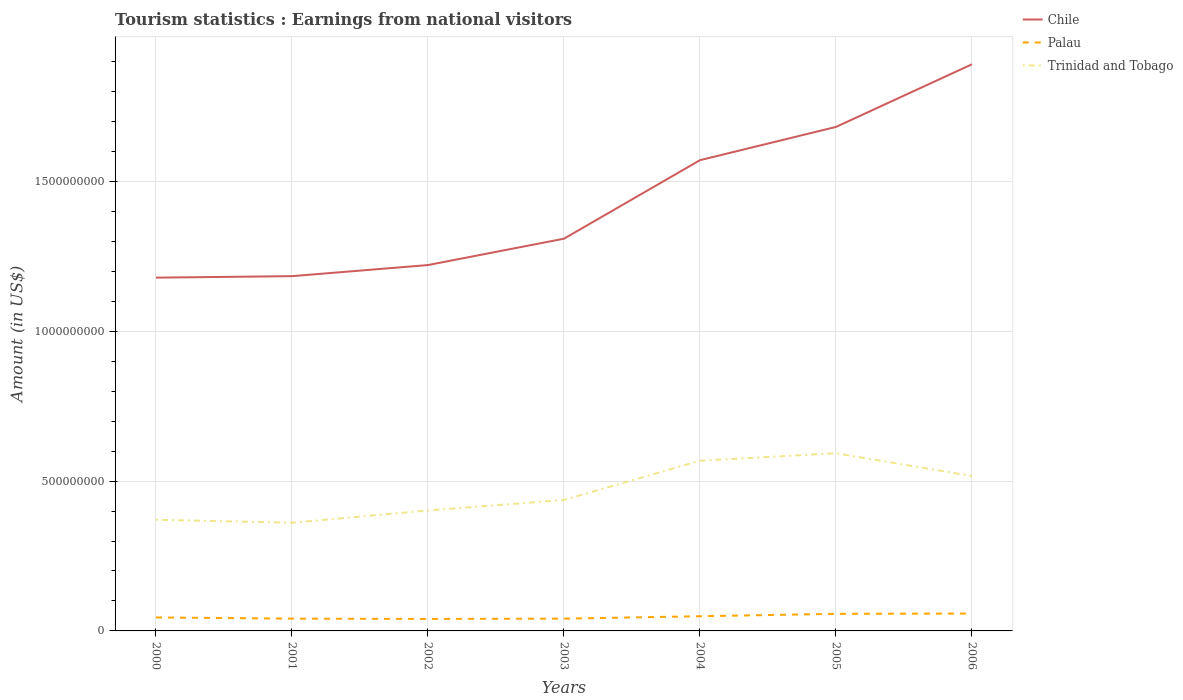Is the number of lines equal to the number of legend labels?
Keep it short and to the point. Yes. Across all years, what is the maximum earnings from national visitors in Chile?
Ensure brevity in your answer.  1.18e+09. What is the total earnings from national visitors in Trinidad and Tobago in the graph?
Provide a succinct answer. 5.10e+07. What is the difference between the highest and the second highest earnings from national visitors in Palau?
Give a very brief answer. 1.80e+07. What is the difference between the highest and the lowest earnings from national visitors in Palau?
Provide a succinct answer. 3. How many lines are there?
Make the answer very short. 3. How many years are there in the graph?
Give a very brief answer. 7. Are the values on the major ticks of Y-axis written in scientific E-notation?
Provide a short and direct response. No. Does the graph contain grids?
Make the answer very short. Yes. How are the legend labels stacked?
Your answer should be compact. Vertical. What is the title of the graph?
Your response must be concise. Tourism statistics : Earnings from national visitors. Does "Heavily indebted poor countries" appear as one of the legend labels in the graph?
Provide a succinct answer. No. What is the Amount (in US$) in Chile in 2000?
Keep it short and to the point. 1.18e+09. What is the Amount (in US$) in Palau in 2000?
Your answer should be very brief. 4.50e+07. What is the Amount (in US$) in Trinidad and Tobago in 2000?
Provide a succinct answer. 3.71e+08. What is the Amount (in US$) of Chile in 2001?
Provide a short and direct response. 1.18e+09. What is the Amount (in US$) of Palau in 2001?
Your answer should be very brief. 4.10e+07. What is the Amount (in US$) of Trinidad and Tobago in 2001?
Give a very brief answer. 3.61e+08. What is the Amount (in US$) in Chile in 2002?
Give a very brief answer. 1.22e+09. What is the Amount (in US$) of Palau in 2002?
Your answer should be very brief. 4.00e+07. What is the Amount (in US$) in Trinidad and Tobago in 2002?
Your answer should be very brief. 4.02e+08. What is the Amount (in US$) in Chile in 2003?
Ensure brevity in your answer.  1.31e+09. What is the Amount (in US$) of Palau in 2003?
Offer a terse response. 4.10e+07. What is the Amount (in US$) of Trinidad and Tobago in 2003?
Make the answer very short. 4.37e+08. What is the Amount (in US$) in Chile in 2004?
Provide a succinct answer. 1.57e+09. What is the Amount (in US$) of Palau in 2004?
Offer a very short reply. 4.90e+07. What is the Amount (in US$) of Trinidad and Tobago in 2004?
Your response must be concise. 5.68e+08. What is the Amount (in US$) in Chile in 2005?
Offer a very short reply. 1.68e+09. What is the Amount (in US$) of Palau in 2005?
Provide a succinct answer. 5.70e+07. What is the Amount (in US$) of Trinidad and Tobago in 2005?
Your answer should be compact. 5.93e+08. What is the Amount (in US$) of Chile in 2006?
Ensure brevity in your answer.  1.89e+09. What is the Amount (in US$) of Palau in 2006?
Your answer should be very brief. 5.80e+07. What is the Amount (in US$) of Trinidad and Tobago in 2006?
Your answer should be very brief. 5.17e+08. Across all years, what is the maximum Amount (in US$) of Chile?
Offer a terse response. 1.89e+09. Across all years, what is the maximum Amount (in US$) of Palau?
Provide a short and direct response. 5.80e+07. Across all years, what is the maximum Amount (in US$) of Trinidad and Tobago?
Ensure brevity in your answer.  5.93e+08. Across all years, what is the minimum Amount (in US$) in Chile?
Your answer should be very brief. 1.18e+09. Across all years, what is the minimum Amount (in US$) of Palau?
Offer a terse response. 4.00e+07. Across all years, what is the minimum Amount (in US$) of Trinidad and Tobago?
Provide a short and direct response. 3.61e+08. What is the total Amount (in US$) of Chile in the graph?
Keep it short and to the point. 1.00e+1. What is the total Amount (in US$) of Palau in the graph?
Make the answer very short. 3.31e+08. What is the total Amount (in US$) in Trinidad and Tobago in the graph?
Your answer should be compact. 3.25e+09. What is the difference between the Amount (in US$) in Chile in 2000 and that in 2001?
Offer a very short reply. -5.00e+06. What is the difference between the Amount (in US$) in Chile in 2000 and that in 2002?
Give a very brief answer. -4.20e+07. What is the difference between the Amount (in US$) of Trinidad and Tobago in 2000 and that in 2002?
Your response must be concise. -3.10e+07. What is the difference between the Amount (in US$) of Chile in 2000 and that in 2003?
Provide a succinct answer. -1.30e+08. What is the difference between the Amount (in US$) of Palau in 2000 and that in 2003?
Make the answer very short. 4.00e+06. What is the difference between the Amount (in US$) of Trinidad and Tobago in 2000 and that in 2003?
Offer a very short reply. -6.60e+07. What is the difference between the Amount (in US$) of Chile in 2000 and that in 2004?
Provide a succinct answer. -3.92e+08. What is the difference between the Amount (in US$) in Palau in 2000 and that in 2004?
Offer a terse response. -4.00e+06. What is the difference between the Amount (in US$) in Trinidad and Tobago in 2000 and that in 2004?
Provide a short and direct response. -1.97e+08. What is the difference between the Amount (in US$) of Chile in 2000 and that in 2005?
Offer a very short reply. -5.03e+08. What is the difference between the Amount (in US$) in Palau in 2000 and that in 2005?
Offer a terse response. -1.20e+07. What is the difference between the Amount (in US$) of Trinidad and Tobago in 2000 and that in 2005?
Offer a very short reply. -2.22e+08. What is the difference between the Amount (in US$) in Chile in 2000 and that in 2006?
Make the answer very short. -7.12e+08. What is the difference between the Amount (in US$) in Palau in 2000 and that in 2006?
Offer a very short reply. -1.30e+07. What is the difference between the Amount (in US$) in Trinidad and Tobago in 2000 and that in 2006?
Provide a short and direct response. -1.46e+08. What is the difference between the Amount (in US$) of Chile in 2001 and that in 2002?
Your answer should be very brief. -3.70e+07. What is the difference between the Amount (in US$) in Palau in 2001 and that in 2002?
Offer a very short reply. 1.00e+06. What is the difference between the Amount (in US$) in Trinidad and Tobago in 2001 and that in 2002?
Your answer should be compact. -4.10e+07. What is the difference between the Amount (in US$) of Chile in 2001 and that in 2003?
Your answer should be very brief. -1.25e+08. What is the difference between the Amount (in US$) in Trinidad and Tobago in 2001 and that in 2003?
Provide a succinct answer. -7.60e+07. What is the difference between the Amount (in US$) in Chile in 2001 and that in 2004?
Keep it short and to the point. -3.87e+08. What is the difference between the Amount (in US$) in Palau in 2001 and that in 2004?
Provide a succinct answer. -8.00e+06. What is the difference between the Amount (in US$) in Trinidad and Tobago in 2001 and that in 2004?
Provide a succinct answer. -2.07e+08. What is the difference between the Amount (in US$) in Chile in 2001 and that in 2005?
Provide a short and direct response. -4.98e+08. What is the difference between the Amount (in US$) in Palau in 2001 and that in 2005?
Your answer should be compact. -1.60e+07. What is the difference between the Amount (in US$) of Trinidad and Tobago in 2001 and that in 2005?
Offer a terse response. -2.32e+08. What is the difference between the Amount (in US$) of Chile in 2001 and that in 2006?
Keep it short and to the point. -7.07e+08. What is the difference between the Amount (in US$) of Palau in 2001 and that in 2006?
Your answer should be very brief. -1.70e+07. What is the difference between the Amount (in US$) in Trinidad and Tobago in 2001 and that in 2006?
Make the answer very short. -1.56e+08. What is the difference between the Amount (in US$) in Chile in 2002 and that in 2003?
Provide a succinct answer. -8.80e+07. What is the difference between the Amount (in US$) in Trinidad and Tobago in 2002 and that in 2003?
Keep it short and to the point. -3.50e+07. What is the difference between the Amount (in US$) of Chile in 2002 and that in 2004?
Offer a terse response. -3.50e+08. What is the difference between the Amount (in US$) of Palau in 2002 and that in 2004?
Provide a succinct answer. -9.00e+06. What is the difference between the Amount (in US$) in Trinidad and Tobago in 2002 and that in 2004?
Give a very brief answer. -1.66e+08. What is the difference between the Amount (in US$) in Chile in 2002 and that in 2005?
Your response must be concise. -4.61e+08. What is the difference between the Amount (in US$) of Palau in 2002 and that in 2005?
Your answer should be compact. -1.70e+07. What is the difference between the Amount (in US$) of Trinidad and Tobago in 2002 and that in 2005?
Give a very brief answer. -1.91e+08. What is the difference between the Amount (in US$) of Chile in 2002 and that in 2006?
Give a very brief answer. -6.70e+08. What is the difference between the Amount (in US$) in Palau in 2002 and that in 2006?
Ensure brevity in your answer.  -1.80e+07. What is the difference between the Amount (in US$) of Trinidad and Tobago in 2002 and that in 2006?
Your answer should be very brief. -1.15e+08. What is the difference between the Amount (in US$) in Chile in 2003 and that in 2004?
Provide a short and direct response. -2.62e+08. What is the difference between the Amount (in US$) in Palau in 2003 and that in 2004?
Offer a very short reply. -8.00e+06. What is the difference between the Amount (in US$) of Trinidad and Tobago in 2003 and that in 2004?
Keep it short and to the point. -1.31e+08. What is the difference between the Amount (in US$) of Chile in 2003 and that in 2005?
Give a very brief answer. -3.73e+08. What is the difference between the Amount (in US$) of Palau in 2003 and that in 2005?
Provide a succinct answer. -1.60e+07. What is the difference between the Amount (in US$) in Trinidad and Tobago in 2003 and that in 2005?
Provide a succinct answer. -1.56e+08. What is the difference between the Amount (in US$) of Chile in 2003 and that in 2006?
Your response must be concise. -5.82e+08. What is the difference between the Amount (in US$) of Palau in 2003 and that in 2006?
Give a very brief answer. -1.70e+07. What is the difference between the Amount (in US$) in Trinidad and Tobago in 2003 and that in 2006?
Your answer should be compact. -8.00e+07. What is the difference between the Amount (in US$) of Chile in 2004 and that in 2005?
Your response must be concise. -1.11e+08. What is the difference between the Amount (in US$) in Palau in 2004 and that in 2005?
Make the answer very short. -8.00e+06. What is the difference between the Amount (in US$) of Trinidad and Tobago in 2004 and that in 2005?
Give a very brief answer. -2.50e+07. What is the difference between the Amount (in US$) in Chile in 2004 and that in 2006?
Provide a short and direct response. -3.20e+08. What is the difference between the Amount (in US$) of Palau in 2004 and that in 2006?
Provide a succinct answer. -9.00e+06. What is the difference between the Amount (in US$) in Trinidad and Tobago in 2004 and that in 2006?
Make the answer very short. 5.10e+07. What is the difference between the Amount (in US$) in Chile in 2005 and that in 2006?
Your answer should be very brief. -2.09e+08. What is the difference between the Amount (in US$) in Trinidad and Tobago in 2005 and that in 2006?
Your answer should be compact. 7.60e+07. What is the difference between the Amount (in US$) in Chile in 2000 and the Amount (in US$) in Palau in 2001?
Offer a very short reply. 1.14e+09. What is the difference between the Amount (in US$) of Chile in 2000 and the Amount (in US$) of Trinidad and Tobago in 2001?
Your response must be concise. 8.18e+08. What is the difference between the Amount (in US$) in Palau in 2000 and the Amount (in US$) in Trinidad and Tobago in 2001?
Your answer should be very brief. -3.16e+08. What is the difference between the Amount (in US$) in Chile in 2000 and the Amount (in US$) in Palau in 2002?
Offer a very short reply. 1.14e+09. What is the difference between the Amount (in US$) of Chile in 2000 and the Amount (in US$) of Trinidad and Tobago in 2002?
Your response must be concise. 7.77e+08. What is the difference between the Amount (in US$) in Palau in 2000 and the Amount (in US$) in Trinidad and Tobago in 2002?
Your answer should be compact. -3.57e+08. What is the difference between the Amount (in US$) of Chile in 2000 and the Amount (in US$) of Palau in 2003?
Provide a short and direct response. 1.14e+09. What is the difference between the Amount (in US$) in Chile in 2000 and the Amount (in US$) in Trinidad and Tobago in 2003?
Your answer should be very brief. 7.42e+08. What is the difference between the Amount (in US$) of Palau in 2000 and the Amount (in US$) of Trinidad and Tobago in 2003?
Make the answer very short. -3.92e+08. What is the difference between the Amount (in US$) of Chile in 2000 and the Amount (in US$) of Palau in 2004?
Your answer should be very brief. 1.13e+09. What is the difference between the Amount (in US$) in Chile in 2000 and the Amount (in US$) in Trinidad and Tobago in 2004?
Your response must be concise. 6.11e+08. What is the difference between the Amount (in US$) of Palau in 2000 and the Amount (in US$) of Trinidad and Tobago in 2004?
Provide a short and direct response. -5.23e+08. What is the difference between the Amount (in US$) in Chile in 2000 and the Amount (in US$) in Palau in 2005?
Your answer should be compact. 1.12e+09. What is the difference between the Amount (in US$) in Chile in 2000 and the Amount (in US$) in Trinidad and Tobago in 2005?
Provide a short and direct response. 5.86e+08. What is the difference between the Amount (in US$) in Palau in 2000 and the Amount (in US$) in Trinidad and Tobago in 2005?
Make the answer very short. -5.48e+08. What is the difference between the Amount (in US$) of Chile in 2000 and the Amount (in US$) of Palau in 2006?
Ensure brevity in your answer.  1.12e+09. What is the difference between the Amount (in US$) of Chile in 2000 and the Amount (in US$) of Trinidad and Tobago in 2006?
Your answer should be compact. 6.62e+08. What is the difference between the Amount (in US$) of Palau in 2000 and the Amount (in US$) of Trinidad and Tobago in 2006?
Offer a terse response. -4.72e+08. What is the difference between the Amount (in US$) of Chile in 2001 and the Amount (in US$) of Palau in 2002?
Make the answer very short. 1.14e+09. What is the difference between the Amount (in US$) in Chile in 2001 and the Amount (in US$) in Trinidad and Tobago in 2002?
Make the answer very short. 7.82e+08. What is the difference between the Amount (in US$) in Palau in 2001 and the Amount (in US$) in Trinidad and Tobago in 2002?
Your answer should be compact. -3.61e+08. What is the difference between the Amount (in US$) of Chile in 2001 and the Amount (in US$) of Palau in 2003?
Your response must be concise. 1.14e+09. What is the difference between the Amount (in US$) in Chile in 2001 and the Amount (in US$) in Trinidad and Tobago in 2003?
Provide a succinct answer. 7.47e+08. What is the difference between the Amount (in US$) of Palau in 2001 and the Amount (in US$) of Trinidad and Tobago in 2003?
Your response must be concise. -3.96e+08. What is the difference between the Amount (in US$) of Chile in 2001 and the Amount (in US$) of Palau in 2004?
Keep it short and to the point. 1.14e+09. What is the difference between the Amount (in US$) in Chile in 2001 and the Amount (in US$) in Trinidad and Tobago in 2004?
Ensure brevity in your answer.  6.16e+08. What is the difference between the Amount (in US$) in Palau in 2001 and the Amount (in US$) in Trinidad and Tobago in 2004?
Make the answer very short. -5.27e+08. What is the difference between the Amount (in US$) in Chile in 2001 and the Amount (in US$) in Palau in 2005?
Your answer should be very brief. 1.13e+09. What is the difference between the Amount (in US$) of Chile in 2001 and the Amount (in US$) of Trinidad and Tobago in 2005?
Your response must be concise. 5.91e+08. What is the difference between the Amount (in US$) in Palau in 2001 and the Amount (in US$) in Trinidad and Tobago in 2005?
Ensure brevity in your answer.  -5.52e+08. What is the difference between the Amount (in US$) of Chile in 2001 and the Amount (in US$) of Palau in 2006?
Keep it short and to the point. 1.13e+09. What is the difference between the Amount (in US$) in Chile in 2001 and the Amount (in US$) in Trinidad and Tobago in 2006?
Offer a very short reply. 6.67e+08. What is the difference between the Amount (in US$) of Palau in 2001 and the Amount (in US$) of Trinidad and Tobago in 2006?
Offer a very short reply. -4.76e+08. What is the difference between the Amount (in US$) in Chile in 2002 and the Amount (in US$) in Palau in 2003?
Provide a succinct answer. 1.18e+09. What is the difference between the Amount (in US$) in Chile in 2002 and the Amount (in US$) in Trinidad and Tobago in 2003?
Give a very brief answer. 7.84e+08. What is the difference between the Amount (in US$) in Palau in 2002 and the Amount (in US$) in Trinidad and Tobago in 2003?
Your answer should be compact. -3.97e+08. What is the difference between the Amount (in US$) in Chile in 2002 and the Amount (in US$) in Palau in 2004?
Offer a terse response. 1.17e+09. What is the difference between the Amount (in US$) in Chile in 2002 and the Amount (in US$) in Trinidad and Tobago in 2004?
Ensure brevity in your answer.  6.53e+08. What is the difference between the Amount (in US$) of Palau in 2002 and the Amount (in US$) of Trinidad and Tobago in 2004?
Provide a succinct answer. -5.28e+08. What is the difference between the Amount (in US$) of Chile in 2002 and the Amount (in US$) of Palau in 2005?
Give a very brief answer. 1.16e+09. What is the difference between the Amount (in US$) of Chile in 2002 and the Amount (in US$) of Trinidad and Tobago in 2005?
Keep it short and to the point. 6.28e+08. What is the difference between the Amount (in US$) of Palau in 2002 and the Amount (in US$) of Trinidad and Tobago in 2005?
Your answer should be compact. -5.53e+08. What is the difference between the Amount (in US$) of Chile in 2002 and the Amount (in US$) of Palau in 2006?
Your answer should be compact. 1.16e+09. What is the difference between the Amount (in US$) in Chile in 2002 and the Amount (in US$) in Trinidad and Tobago in 2006?
Offer a very short reply. 7.04e+08. What is the difference between the Amount (in US$) in Palau in 2002 and the Amount (in US$) in Trinidad and Tobago in 2006?
Keep it short and to the point. -4.77e+08. What is the difference between the Amount (in US$) of Chile in 2003 and the Amount (in US$) of Palau in 2004?
Provide a succinct answer. 1.26e+09. What is the difference between the Amount (in US$) in Chile in 2003 and the Amount (in US$) in Trinidad and Tobago in 2004?
Keep it short and to the point. 7.41e+08. What is the difference between the Amount (in US$) of Palau in 2003 and the Amount (in US$) of Trinidad and Tobago in 2004?
Offer a terse response. -5.27e+08. What is the difference between the Amount (in US$) of Chile in 2003 and the Amount (in US$) of Palau in 2005?
Provide a succinct answer. 1.25e+09. What is the difference between the Amount (in US$) of Chile in 2003 and the Amount (in US$) of Trinidad and Tobago in 2005?
Provide a succinct answer. 7.16e+08. What is the difference between the Amount (in US$) in Palau in 2003 and the Amount (in US$) in Trinidad and Tobago in 2005?
Your answer should be compact. -5.52e+08. What is the difference between the Amount (in US$) of Chile in 2003 and the Amount (in US$) of Palau in 2006?
Your answer should be very brief. 1.25e+09. What is the difference between the Amount (in US$) in Chile in 2003 and the Amount (in US$) in Trinidad and Tobago in 2006?
Keep it short and to the point. 7.92e+08. What is the difference between the Amount (in US$) of Palau in 2003 and the Amount (in US$) of Trinidad and Tobago in 2006?
Provide a short and direct response. -4.76e+08. What is the difference between the Amount (in US$) of Chile in 2004 and the Amount (in US$) of Palau in 2005?
Your response must be concise. 1.51e+09. What is the difference between the Amount (in US$) in Chile in 2004 and the Amount (in US$) in Trinidad and Tobago in 2005?
Make the answer very short. 9.78e+08. What is the difference between the Amount (in US$) of Palau in 2004 and the Amount (in US$) of Trinidad and Tobago in 2005?
Make the answer very short. -5.44e+08. What is the difference between the Amount (in US$) of Chile in 2004 and the Amount (in US$) of Palau in 2006?
Give a very brief answer. 1.51e+09. What is the difference between the Amount (in US$) in Chile in 2004 and the Amount (in US$) in Trinidad and Tobago in 2006?
Make the answer very short. 1.05e+09. What is the difference between the Amount (in US$) in Palau in 2004 and the Amount (in US$) in Trinidad and Tobago in 2006?
Provide a short and direct response. -4.68e+08. What is the difference between the Amount (in US$) in Chile in 2005 and the Amount (in US$) in Palau in 2006?
Your answer should be compact. 1.62e+09. What is the difference between the Amount (in US$) in Chile in 2005 and the Amount (in US$) in Trinidad and Tobago in 2006?
Give a very brief answer. 1.16e+09. What is the difference between the Amount (in US$) in Palau in 2005 and the Amount (in US$) in Trinidad and Tobago in 2006?
Give a very brief answer. -4.60e+08. What is the average Amount (in US$) of Chile per year?
Provide a short and direct response. 1.43e+09. What is the average Amount (in US$) in Palau per year?
Make the answer very short. 4.73e+07. What is the average Amount (in US$) of Trinidad and Tobago per year?
Offer a terse response. 4.64e+08. In the year 2000, what is the difference between the Amount (in US$) of Chile and Amount (in US$) of Palau?
Your answer should be very brief. 1.13e+09. In the year 2000, what is the difference between the Amount (in US$) of Chile and Amount (in US$) of Trinidad and Tobago?
Give a very brief answer. 8.08e+08. In the year 2000, what is the difference between the Amount (in US$) of Palau and Amount (in US$) of Trinidad and Tobago?
Give a very brief answer. -3.26e+08. In the year 2001, what is the difference between the Amount (in US$) in Chile and Amount (in US$) in Palau?
Your answer should be very brief. 1.14e+09. In the year 2001, what is the difference between the Amount (in US$) in Chile and Amount (in US$) in Trinidad and Tobago?
Offer a very short reply. 8.23e+08. In the year 2001, what is the difference between the Amount (in US$) of Palau and Amount (in US$) of Trinidad and Tobago?
Give a very brief answer. -3.20e+08. In the year 2002, what is the difference between the Amount (in US$) of Chile and Amount (in US$) of Palau?
Your answer should be very brief. 1.18e+09. In the year 2002, what is the difference between the Amount (in US$) of Chile and Amount (in US$) of Trinidad and Tobago?
Your answer should be compact. 8.19e+08. In the year 2002, what is the difference between the Amount (in US$) in Palau and Amount (in US$) in Trinidad and Tobago?
Make the answer very short. -3.62e+08. In the year 2003, what is the difference between the Amount (in US$) of Chile and Amount (in US$) of Palau?
Your answer should be very brief. 1.27e+09. In the year 2003, what is the difference between the Amount (in US$) in Chile and Amount (in US$) in Trinidad and Tobago?
Your answer should be very brief. 8.72e+08. In the year 2003, what is the difference between the Amount (in US$) in Palau and Amount (in US$) in Trinidad and Tobago?
Your answer should be compact. -3.96e+08. In the year 2004, what is the difference between the Amount (in US$) of Chile and Amount (in US$) of Palau?
Your answer should be very brief. 1.52e+09. In the year 2004, what is the difference between the Amount (in US$) of Chile and Amount (in US$) of Trinidad and Tobago?
Ensure brevity in your answer.  1.00e+09. In the year 2004, what is the difference between the Amount (in US$) of Palau and Amount (in US$) of Trinidad and Tobago?
Provide a short and direct response. -5.19e+08. In the year 2005, what is the difference between the Amount (in US$) of Chile and Amount (in US$) of Palau?
Provide a short and direct response. 1.62e+09. In the year 2005, what is the difference between the Amount (in US$) of Chile and Amount (in US$) of Trinidad and Tobago?
Your answer should be very brief. 1.09e+09. In the year 2005, what is the difference between the Amount (in US$) of Palau and Amount (in US$) of Trinidad and Tobago?
Keep it short and to the point. -5.36e+08. In the year 2006, what is the difference between the Amount (in US$) of Chile and Amount (in US$) of Palau?
Keep it short and to the point. 1.83e+09. In the year 2006, what is the difference between the Amount (in US$) of Chile and Amount (in US$) of Trinidad and Tobago?
Provide a short and direct response. 1.37e+09. In the year 2006, what is the difference between the Amount (in US$) of Palau and Amount (in US$) of Trinidad and Tobago?
Provide a succinct answer. -4.59e+08. What is the ratio of the Amount (in US$) in Palau in 2000 to that in 2001?
Give a very brief answer. 1.1. What is the ratio of the Amount (in US$) in Trinidad and Tobago in 2000 to that in 2001?
Offer a very short reply. 1.03. What is the ratio of the Amount (in US$) of Chile in 2000 to that in 2002?
Your answer should be very brief. 0.97. What is the ratio of the Amount (in US$) of Trinidad and Tobago in 2000 to that in 2002?
Provide a succinct answer. 0.92. What is the ratio of the Amount (in US$) in Chile in 2000 to that in 2003?
Your answer should be very brief. 0.9. What is the ratio of the Amount (in US$) of Palau in 2000 to that in 2003?
Your answer should be very brief. 1.1. What is the ratio of the Amount (in US$) in Trinidad and Tobago in 2000 to that in 2003?
Provide a short and direct response. 0.85. What is the ratio of the Amount (in US$) of Chile in 2000 to that in 2004?
Offer a very short reply. 0.75. What is the ratio of the Amount (in US$) of Palau in 2000 to that in 2004?
Ensure brevity in your answer.  0.92. What is the ratio of the Amount (in US$) of Trinidad and Tobago in 2000 to that in 2004?
Provide a short and direct response. 0.65. What is the ratio of the Amount (in US$) in Chile in 2000 to that in 2005?
Provide a succinct answer. 0.7. What is the ratio of the Amount (in US$) in Palau in 2000 to that in 2005?
Give a very brief answer. 0.79. What is the ratio of the Amount (in US$) in Trinidad and Tobago in 2000 to that in 2005?
Offer a very short reply. 0.63. What is the ratio of the Amount (in US$) in Chile in 2000 to that in 2006?
Ensure brevity in your answer.  0.62. What is the ratio of the Amount (in US$) in Palau in 2000 to that in 2006?
Keep it short and to the point. 0.78. What is the ratio of the Amount (in US$) of Trinidad and Tobago in 2000 to that in 2006?
Give a very brief answer. 0.72. What is the ratio of the Amount (in US$) of Chile in 2001 to that in 2002?
Provide a short and direct response. 0.97. What is the ratio of the Amount (in US$) in Palau in 2001 to that in 2002?
Offer a very short reply. 1.02. What is the ratio of the Amount (in US$) in Trinidad and Tobago in 2001 to that in 2002?
Your answer should be compact. 0.9. What is the ratio of the Amount (in US$) in Chile in 2001 to that in 2003?
Offer a very short reply. 0.9. What is the ratio of the Amount (in US$) in Trinidad and Tobago in 2001 to that in 2003?
Offer a terse response. 0.83. What is the ratio of the Amount (in US$) in Chile in 2001 to that in 2004?
Keep it short and to the point. 0.75. What is the ratio of the Amount (in US$) of Palau in 2001 to that in 2004?
Offer a very short reply. 0.84. What is the ratio of the Amount (in US$) in Trinidad and Tobago in 2001 to that in 2004?
Ensure brevity in your answer.  0.64. What is the ratio of the Amount (in US$) of Chile in 2001 to that in 2005?
Your answer should be compact. 0.7. What is the ratio of the Amount (in US$) of Palau in 2001 to that in 2005?
Offer a terse response. 0.72. What is the ratio of the Amount (in US$) of Trinidad and Tobago in 2001 to that in 2005?
Make the answer very short. 0.61. What is the ratio of the Amount (in US$) of Chile in 2001 to that in 2006?
Offer a very short reply. 0.63. What is the ratio of the Amount (in US$) in Palau in 2001 to that in 2006?
Offer a terse response. 0.71. What is the ratio of the Amount (in US$) of Trinidad and Tobago in 2001 to that in 2006?
Provide a succinct answer. 0.7. What is the ratio of the Amount (in US$) of Chile in 2002 to that in 2003?
Provide a short and direct response. 0.93. What is the ratio of the Amount (in US$) in Palau in 2002 to that in 2003?
Provide a succinct answer. 0.98. What is the ratio of the Amount (in US$) of Trinidad and Tobago in 2002 to that in 2003?
Offer a very short reply. 0.92. What is the ratio of the Amount (in US$) of Chile in 2002 to that in 2004?
Make the answer very short. 0.78. What is the ratio of the Amount (in US$) in Palau in 2002 to that in 2004?
Provide a short and direct response. 0.82. What is the ratio of the Amount (in US$) in Trinidad and Tobago in 2002 to that in 2004?
Keep it short and to the point. 0.71. What is the ratio of the Amount (in US$) of Chile in 2002 to that in 2005?
Give a very brief answer. 0.73. What is the ratio of the Amount (in US$) in Palau in 2002 to that in 2005?
Your answer should be compact. 0.7. What is the ratio of the Amount (in US$) in Trinidad and Tobago in 2002 to that in 2005?
Provide a short and direct response. 0.68. What is the ratio of the Amount (in US$) of Chile in 2002 to that in 2006?
Your answer should be very brief. 0.65. What is the ratio of the Amount (in US$) of Palau in 2002 to that in 2006?
Keep it short and to the point. 0.69. What is the ratio of the Amount (in US$) in Trinidad and Tobago in 2002 to that in 2006?
Ensure brevity in your answer.  0.78. What is the ratio of the Amount (in US$) of Chile in 2003 to that in 2004?
Keep it short and to the point. 0.83. What is the ratio of the Amount (in US$) in Palau in 2003 to that in 2004?
Give a very brief answer. 0.84. What is the ratio of the Amount (in US$) of Trinidad and Tobago in 2003 to that in 2004?
Your answer should be compact. 0.77. What is the ratio of the Amount (in US$) of Chile in 2003 to that in 2005?
Your answer should be compact. 0.78. What is the ratio of the Amount (in US$) in Palau in 2003 to that in 2005?
Give a very brief answer. 0.72. What is the ratio of the Amount (in US$) of Trinidad and Tobago in 2003 to that in 2005?
Provide a succinct answer. 0.74. What is the ratio of the Amount (in US$) in Chile in 2003 to that in 2006?
Offer a terse response. 0.69. What is the ratio of the Amount (in US$) in Palau in 2003 to that in 2006?
Provide a short and direct response. 0.71. What is the ratio of the Amount (in US$) of Trinidad and Tobago in 2003 to that in 2006?
Provide a succinct answer. 0.85. What is the ratio of the Amount (in US$) of Chile in 2004 to that in 2005?
Keep it short and to the point. 0.93. What is the ratio of the Amount (in US$) in Palau in 2004 to that in 2005?
Offer a very short reply. 0.86. What is the ratio of the Amount (in US$) in Trinidad and Tobago in 2004 to that in 2005?
Make the answer very short. 0.96. What is the ratio of the Amount (in US$) in Chile in 2004 to that in 2006?
Keep it short and to the point. 0.83. What is the ratio of the Amount (in US$) in Palau in 2004 to that in 2006?
Your response must be concise. 0.84. What is the ratio of the Amount (in US$) in Trinidad and Tobago in 2004 to that in 2006?
Offer a terse response. 1.1. What is the ratio of the Amount (in US$) in Chile in 2005 to that in 2006?
Give a very brief answer. 0.89. What is the ratio of the Amount (in US$) of Palau in 2005 to that in 2006?
Your answer should be very brief. 0.98. What is the ratio of the Amount (in US$) in Trinidad and Tobago in 2005 to that in 2006?
Provide a succinct answer. 1.15. What is the difference between the highest and the second highest Amount (in US$) in Chile?
Ensure brevity in your answer.  2.09e+08. What is the difference between the highest and the second highest Amount (in US$) in Trinidad and Tobago?
Your answer should be very brief. 2.50e+07. What is the difference between the highest and the lowest Amount (in US$) in Chile?
Your response must be concise. 7.12e+08. What is the difference between the highest and the lowest Amount (in US$) of Palau?
Make the answer very short. 1.80e+07. What is the difference between the highest and the lowest Amount (in US$) in Trinidad and Tobago?
Provide a short and direct response. 2.32e+08. 